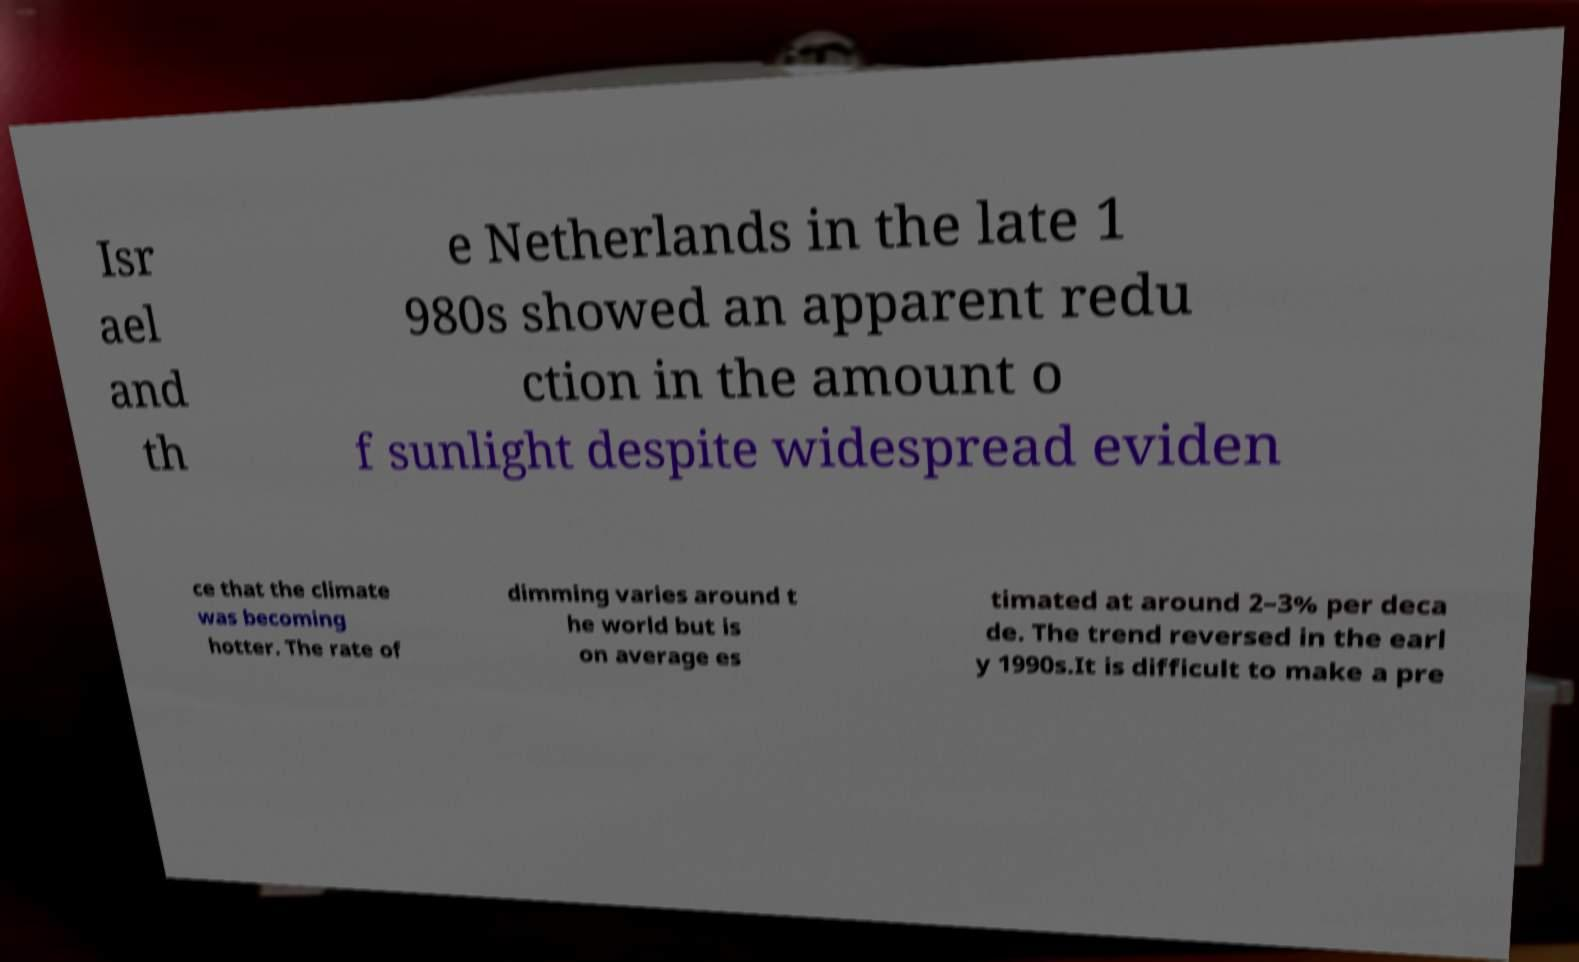Could you extract and type out the text from this image? Isr ael and th e Netherlands in the late 1 980s showed an apparent redu ction in the amount o f sunlight despite widespread eviden ce that the climate was becoming hotter. The rate of dimming varies around t he world but is on average es timated at around 2–3% per deca de. The trend reversed in the earl y 1990s.It is difficult to make a pre 